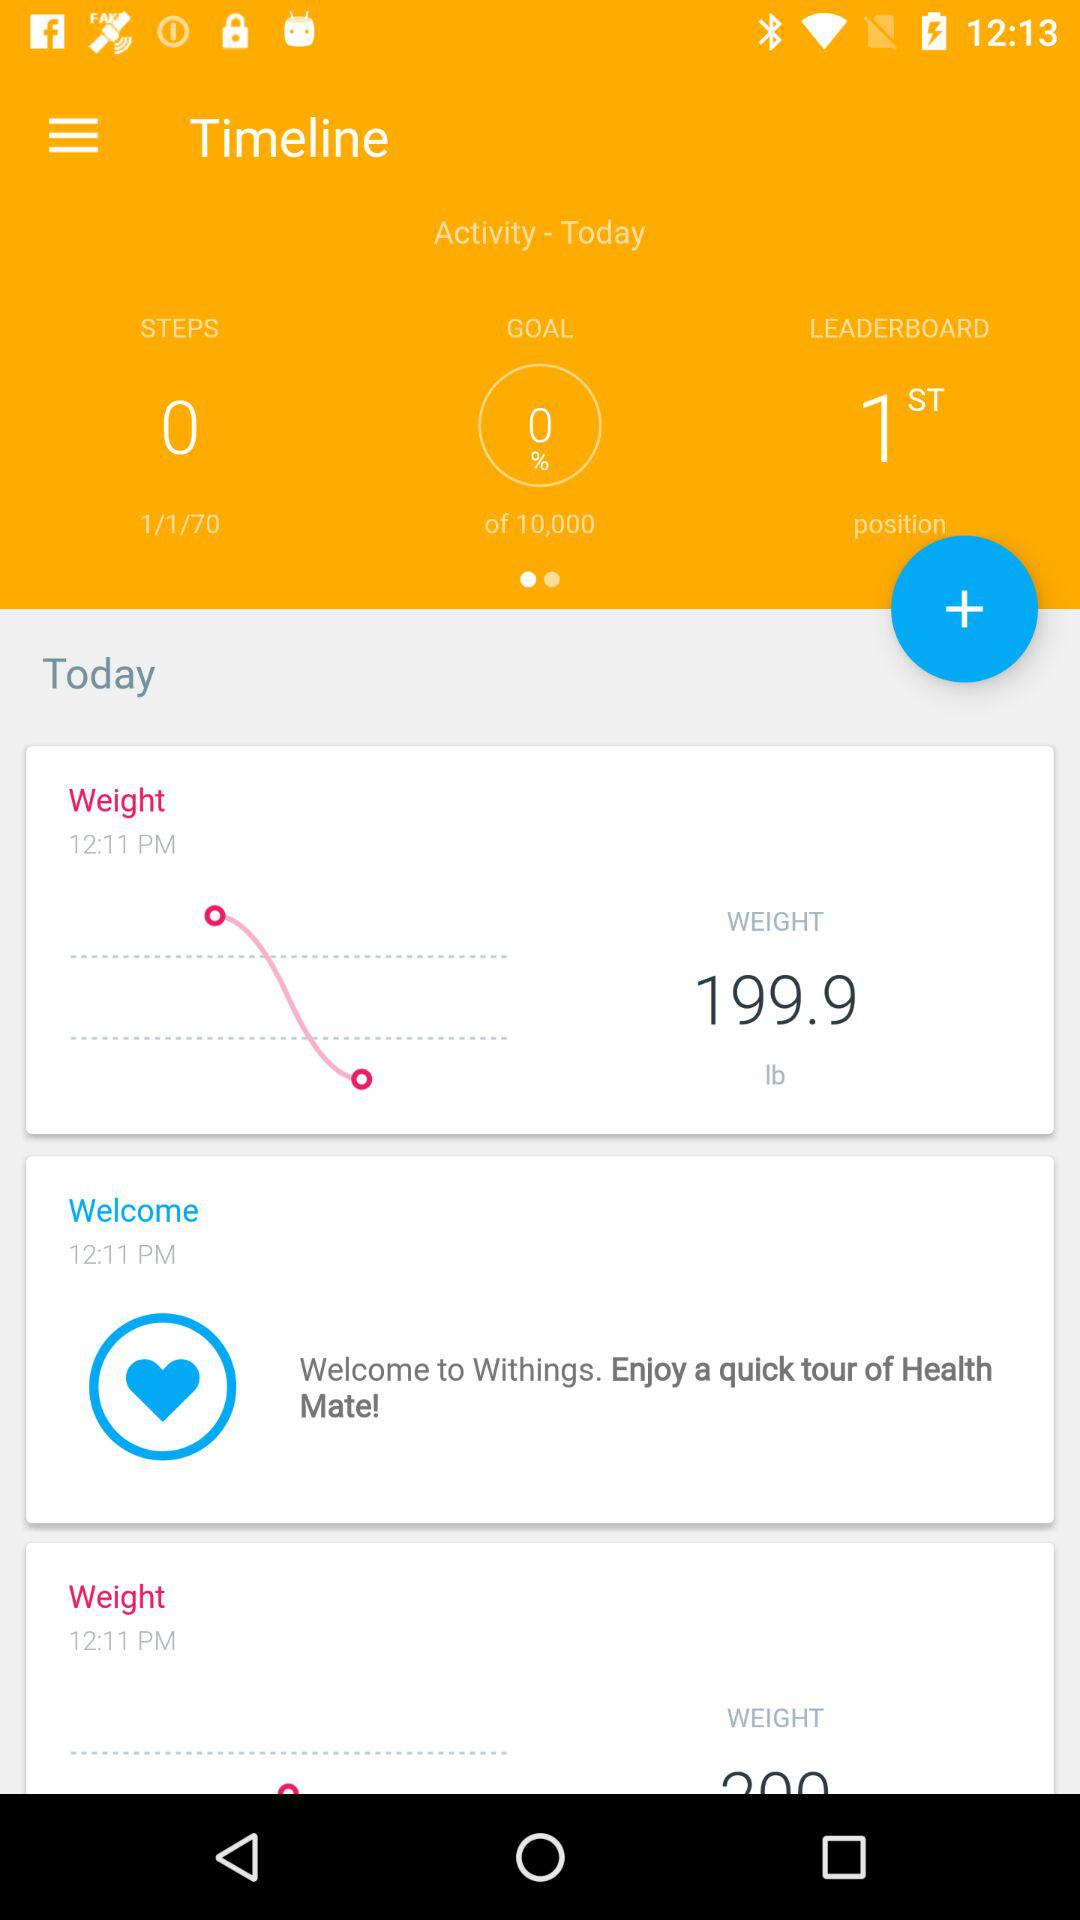How many more steps do I have to take to reach my goal?
Answer the question using a single word or phrase. 9999 